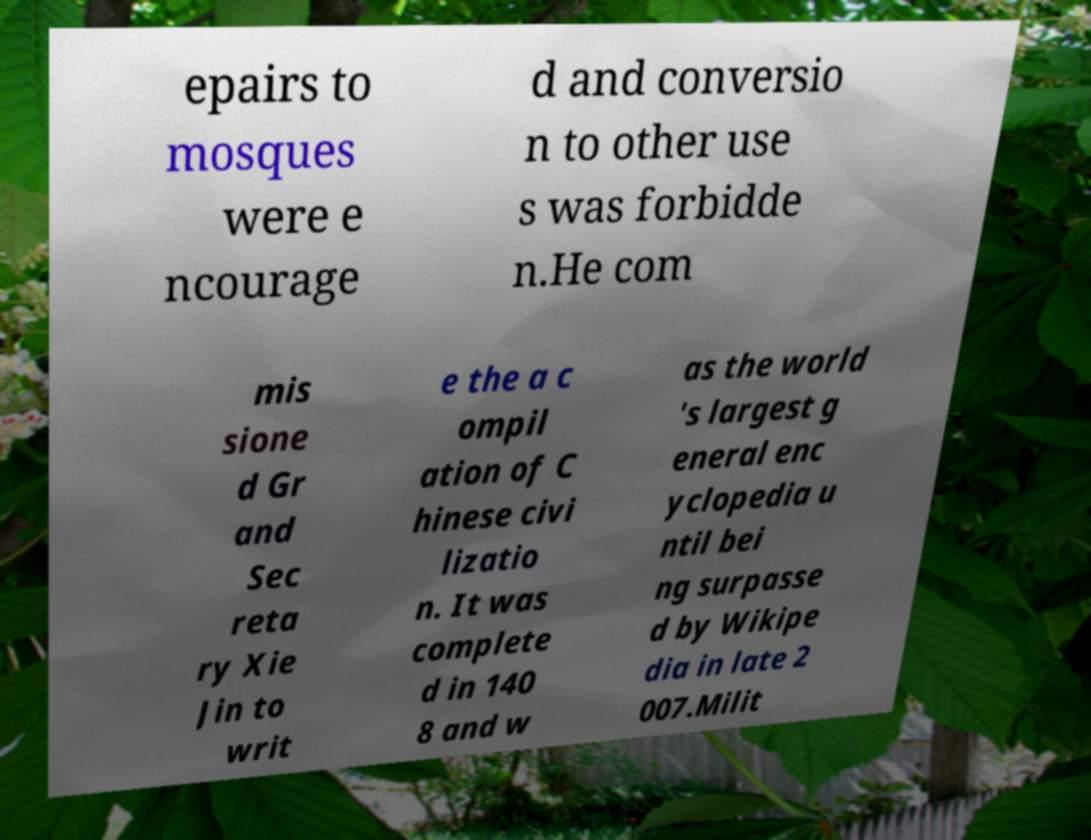Please read and relay the text visible in this image. What does it say? epairs to mosques were e ncourage d and conversio n to other use s was forbidde n.He com mis sione d Gr and Sec reta ry Xie Jin to writ e the a c ompil ation of C hinese civi lizatio n. It was complete d in 140 8 and w as the world 's largest g eneral enc yclopedia u ntil bei ng surpasse d by Wikipe dia in late 2 007.Milit 